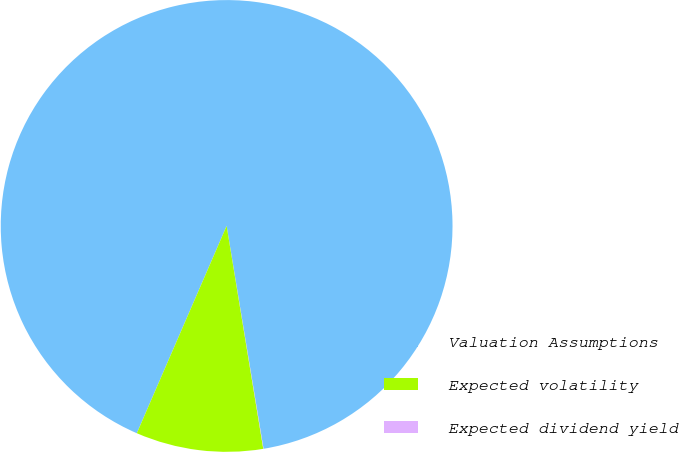Convert chart. <chart><loc_0><loc_0><loc_500><loc_500><pie_chart><fcel>Valuation Assumptions<fcel>Expected volatility<fcel>Expected dividend yield<nl><fcel>90.88%<fcel>9.1%<fcel>0.02%<nl></chart> 